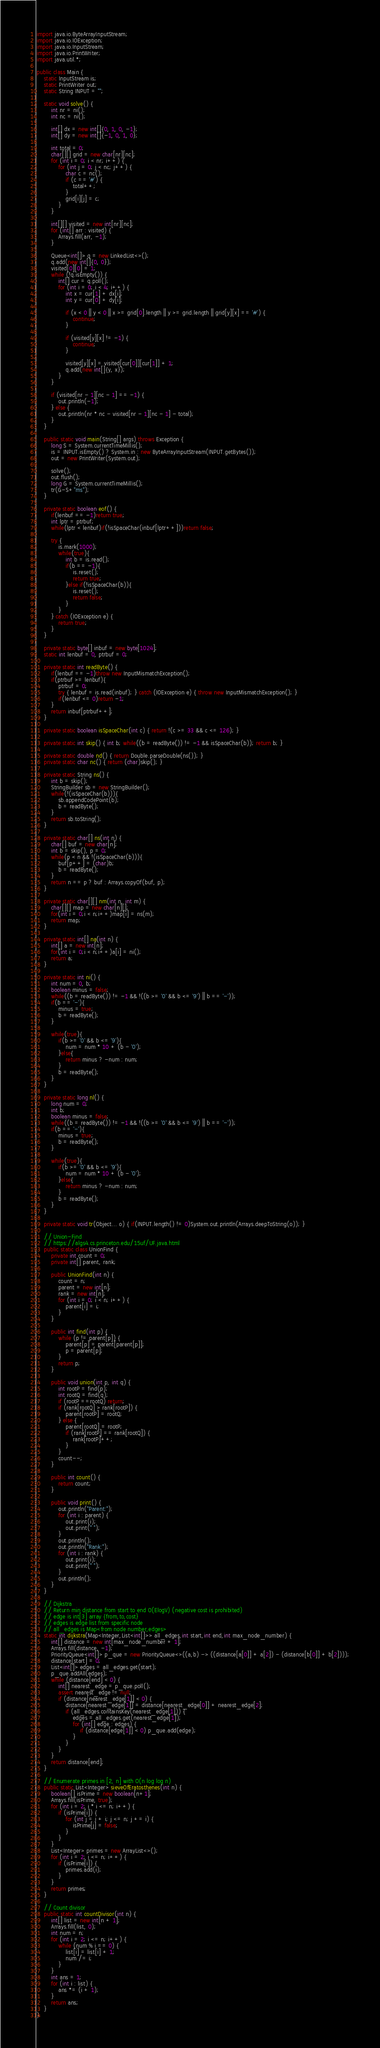<code> <loc_0><loc_0><loc_500><loc_500><_Java_>import java.io.ByteArrayInputStream;
import java.io.IOException;
import java.io.InputStream;
import java.io.PrintWriter;
import java.util.*;

public class Main {
    static InputStream is;
    static PrintWriter out;
    static String INPUT = "";

    static void solve() {
        int nr = ni();
        int nc = ni();

        int[] dx = new int[]{0, 1, 0, -1};
        int[] dy = new int[]{-1, 0, 1, 0};

        int total = 0;
        char[][] grid = new char[nr][nc];
        for (int i = 0; i < nr; i++) {
            for (int j = 0; j < nc; j++) {
                char c = nc();
                if (c == '#') {
                    total++;
                }
                grid[i][j] = c;
            }
        }

        int[][] visited = new int[nr][nc];
        for (int[] arr : visited) {
            Arrays.fill(arr, -1);
        }

        Queue<int[]> q = new LinkedList<>();
        q.add(new int[]{0, 0});
        visited[0][0] = 1;
        while (!q.isEmpty()) {
            int[] cur = q.poll();
            for (int i = 0; i < 4; i++) {
                int x = cur[1] + dx[i];
                int y = cur[0] + dy[i];

                if (x < 0 || y < 0 || x >= grid[0].length || y >= grid.length || grid[y][x] == '#') {
                    continue;
                }

                if (visited[y][x] != -1) {
                    continue;
                }

                visited[y][x] = visited[cur[0]][cur[1]] + 1;
                q.add(new int[]{y, x});
            }
        }

        if (visited[nr - 1][nc - 1] == -1) {
            out.println(-1);
        } else {
            out.println(nr * nc - visited[nr - 1][nc - 1] - total);
        }
    }

    public static void main(String[] args) throws Exception {
        long S = System.currentTimeMillis();
        is = INPUT.isEmpty() ? System.in : new ByteArrayInputStream(INPUT.getBytes());
        out = new PrintWriter(System.out);

        solve();
        out.flush();
        long G = System.currentTimeMillis();
        tr(G-S+"ms");
    }

    private static boolean eof() {
        if(lenbuf == -1)return true;
        int lptr = ptrbuf;
        while(lptr < lenbuf)if(!isSpaceChar(inbuf[lptr++]))return false;

        try {
            is.mark(1000);
            while(true){
                int b = is.read();
                if(b == -1){
                    is.reset();
                    return true;
                }else if(!isSpaceChar(b)){
                    is.reset();
                    return false;
                }
            }
        } catch (IOException e) {
            return true;
        }
    }

    private static byte[] inbuf = new byte[1024];
    static int lenbuf = 0, ptrbuf = 0;

    private static int readByte() {
        if(lenbuf == -1)throw new InputMismatchException();
        if(ptrbuf >= lenbuf){
            ptrbuf = 0;
            try { lenbuf = is.read(inbuf); } catch (IOException e) { throw new InputMismatchException(); }
            if(lenbuf <= 0)return -1;
        }
        return inbuf[ptrbuf++];
    }

    private static boolean isSpaceChar(int c) { return !(c >= 33 && c <= 126); }

    private static int skip() { int b; while((b = readByte()) != -1 && isSpaceChar(b)); return b; }

    private static double nd() { return Double.parseDouble(ns()); }
    private static char nc() { return (char)skip(); }

    private static String ns() {
        int b = skip();
        StringBuilder sb = new StringBuilder();
        while(!(isSpaceChar(b))){
            sb.appendCodePoint(b);
            b = readByte();
        }
        return sb.toString();
    }

    private static char[] ns(int n) {
        char[] buf = new char[n];
        int b = skip(), p = 0;
        while(p < n && !(isSpaceChar(b))){
            buf[p++] = (char)b;
            b = readByte();
        }
        return n == p ? buf : Arrays.copyOf(buf, p);
    }

    private static char[][] nm(int n, int m) {
        char[][] map = new char[n][];
        for(int i = 0;i < n;i++)map[i] = ns(m);
        return map;
    }

    private static int[] na(int n) {
        int[] a = new int[n];
        for(int i = 0;i < n;i++)a[i] = ni();
        return a;
    }

    private static int ni() {
        int num = 0, b;
        boolean minus = false;
        while((b = readByte()) != -1 && !((b >= '0' && b <= '9') || b == '-'));
        if(b == '-'){
            minus = true;
            b = readByte();
        }

        while(true){
            if(b >= '0' && b <= '9'){
                num = num * 10 + (b - '0');
            }else{
                return minus ? -num : num;
            }
            b = readByte();
        }
    }

    private static long nl() {
        long num = 0;
        int b;
        boolean minus = false;
        while((b = readByte()) != -1 && !((b >= '0' && b <= '9') || b == '-'));
        if(b == '-'){
            minus = true;
            b = readByte();
        }

        while(true){
            if(b >= '0' && b <= '9'){
                num = num * 10 + (b - '0');
            }else{
                return minus ? -num : num;
            }
            b = readByte();
        }
    }

    private static void tr(Object... o) { if(INPUT.length() != 0)System.out.println(Arrays.deepToString(o)); }

    // Union-Find
    // https://algs4.cs.princeton.edu/15uf/UF.java.html
    public static class UnionFind {
        private int count = 0;
        private int[] parent, rank;

        public UnionFind(int n) {
            count = n;
            parent = new int[n];
            rank = new int[n];
            for (int i = 0; i < n; i++) {
                parent[i] = i;
            }
        }

        public int find(int p) {
            while (p != parent[p]) {
                parent[p] = parent[parent[p]];
                p = parent[p];
            }
            return p;
        }

        public void union(int p, int q) {
            int rootP = find(p);
            int rootQ = find(q);
            if (rootP ==rootQ) return;
            if (rank[rootQ] > rank[rootP]) {
                parent[rootP] = rootQ;
            } else {
                parent[rootQ] = rootP;
                if (rank[rootP] == rank[rootQ]) {
                    rank[rootP]++;
                }
            }
            count--;
        }

        public int count() {
            return count;
        }

        public void print() {
            out.println("Parent:");
            for (int i : parent) {
                out.print(i);
                out.print(" ");
            }
            out.println();
            out.println("Rank:");
            for (int i : rank) {
                out.print(i);
                out.print(" ");
            }
            out.println();
        }
    }

    // Dijkstra
    // Return min distance from start to end O(ElogV) (negative cost is prohibited)
    // edge is int[3] array {from,to,cost}
    // edges is edge list from specific node
    // all_edges is Map<from node number,edges>
    static int dijkstra(Map<Integer,List<int[]>> all_edges,int start,int end,int max_node_number) {
        int[] distance = new int[max_node_number + 1];
        Arrays.fill(distance, -1);
        PriorityQueue<int[]> p_que = new PriorityQueue<>((a,b) -> ((distance[a[0]] + a[2]) - (distance[b[0]] + b[2])));
        distance[start] = 0;
        List<int[]> edges = all_edges.get(start);
        p_que.addAll(edges);
        while (distance[end] < 0) {
            int[] nearest_edge = p_que.poll();
            assert nearest_edge != null;
            if (distance[nearest_edge[1]] < 0) {
                distance[nearest_edge[1]] = distance[nearest_edge[0]] + nearest_edge[2];
                if (all_edges.containsKey(nearest_edge[1])) {
                    edges = all_edges.get(nearest_edge[1]);
                    for (int[] edge : edges) {
                        if (distance[edge[1]] < 0) p_que.add(edge);
                    }
                }
            }
        }
        return distance[end];
    }

    // Enumerate primes in [2, n] with O(n log log n)
    public static List<Integer> sieveOfEratosthenes(int n) {
        boolean[] isPrime = new boolean[n+1];
        Arrays.fill(isPrime, true);
        for (int i = 2; i * i <= n; i++) {
            if (isPrime[i]) {
                for (int j = i + i; j <= n; j += i) {
                    isPrime[j] = false;
                }
            }
        }
        List<Integer> primes = new ArrayList<>();
        for (int i = 2; i <= n; i++) {
            if (isPrime[i]) {
                primes.add(i);
            }
        }
        return primes;
    }

    // Count divisor
    public static int countDivisor(int n) {
        int[] list = new int[n + 1];
        Arrays.fill(list, 0);
        int num = n;
        for (int i = 2; i <= n; i++) {
            while (num % i == 0) {
                list[i] = list[i] + 1;
                num /= i;
            }
        }
        int ans = 1;
        for (int i : list) {
            ans *= (i + 1);
        }
        return ans;
    }
}
</code> 